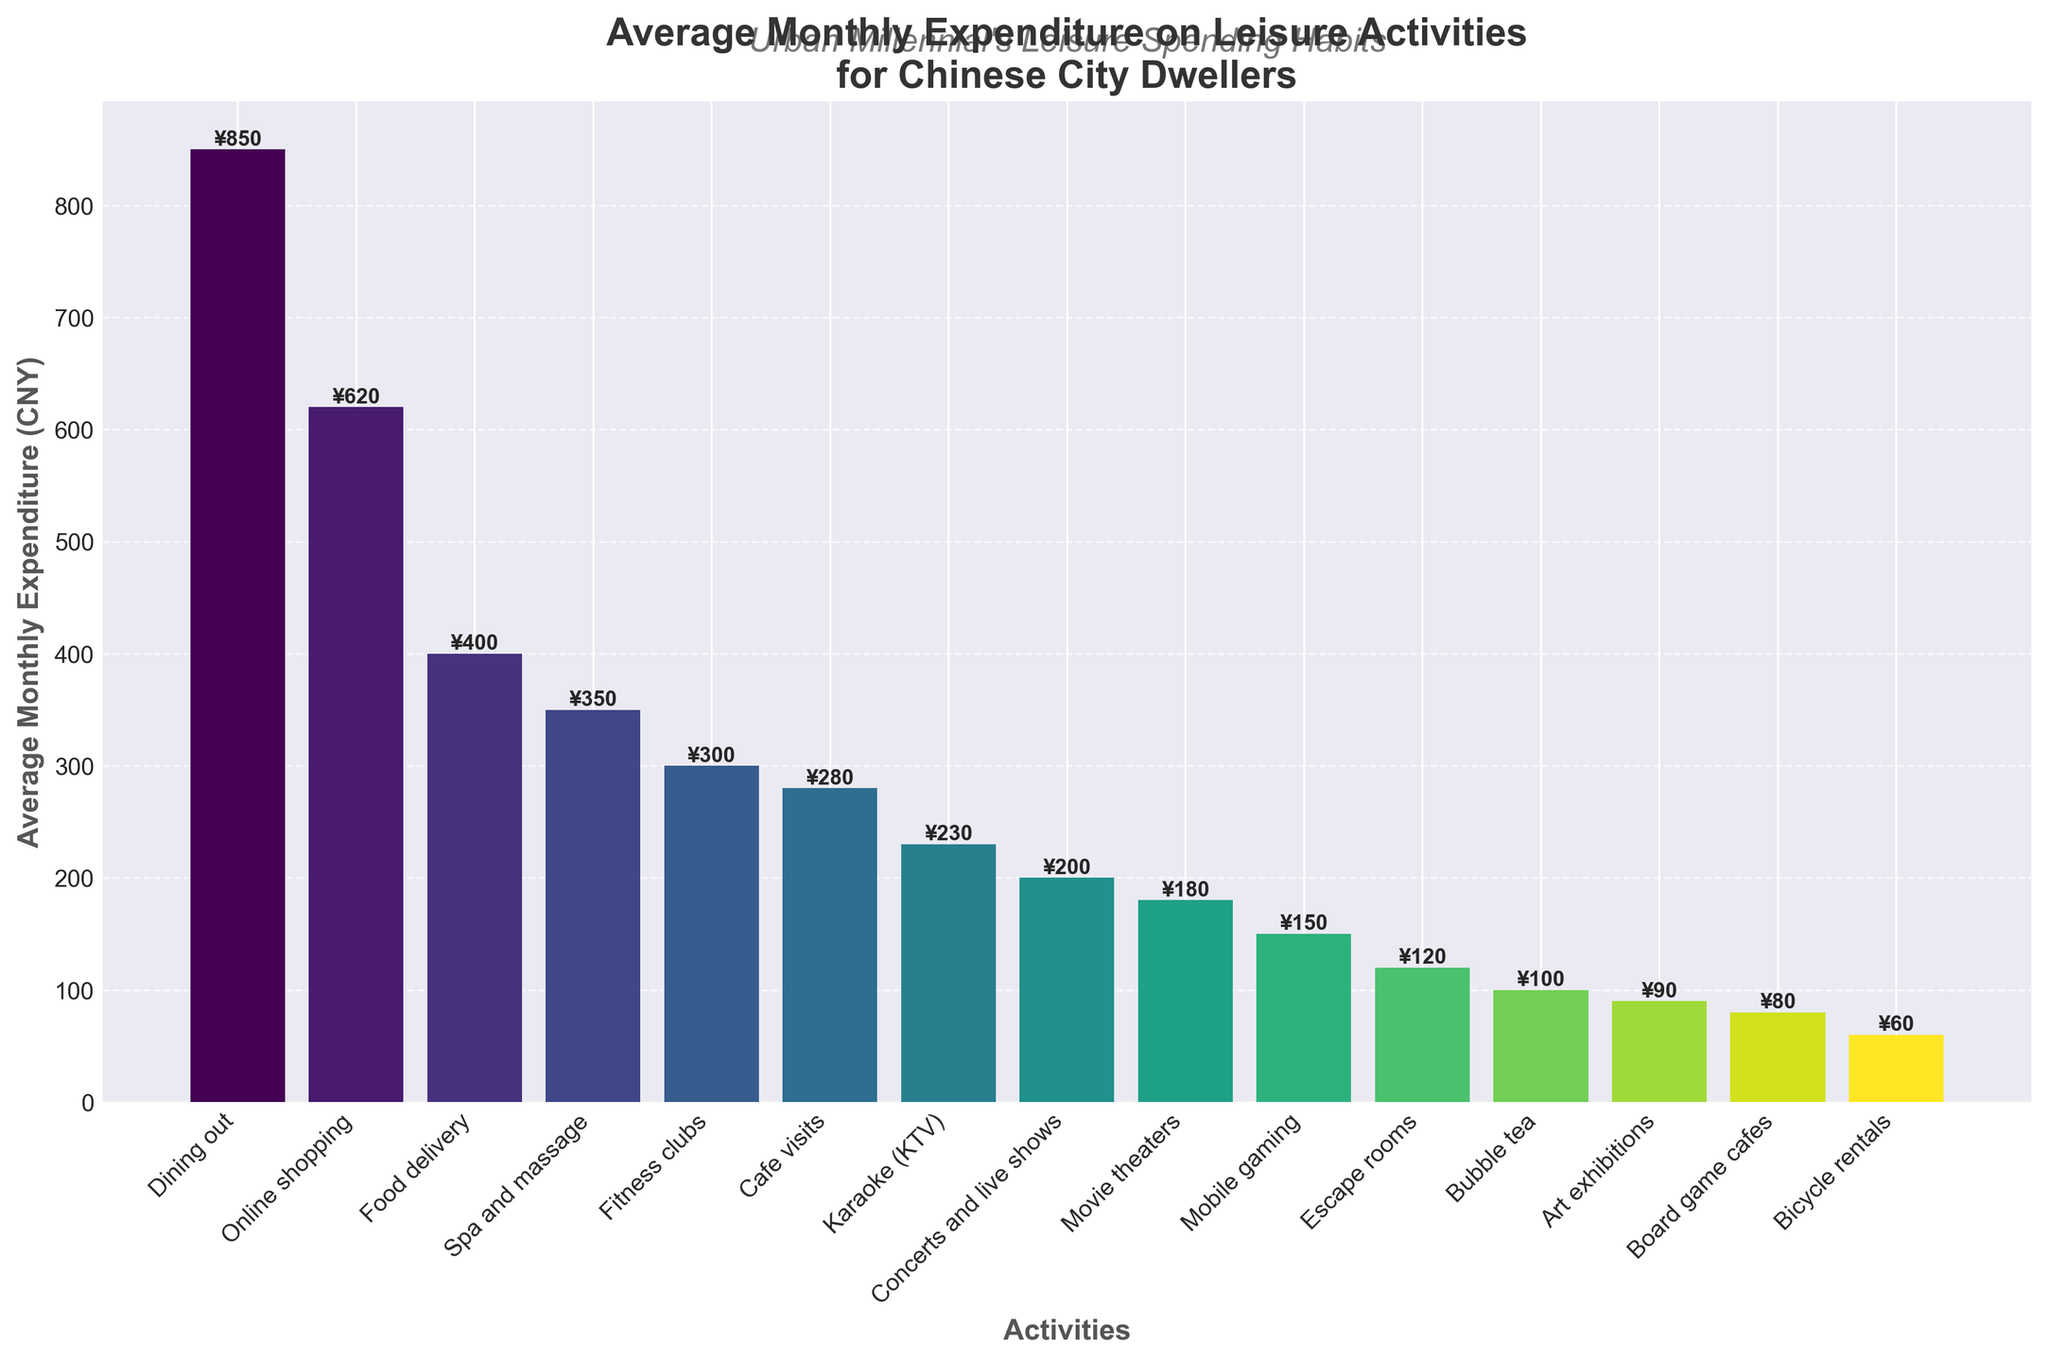What is the second most expensive leisure activity? From the figure, the most expensive activity is Dining out. The second bar after Dining out represents Food delivery, which has the second highest average monthly expenditure.
Answer: Food delivery What is the total monthly expenditure on both Cafe visits and Bike rentals? Cafe visits have a monthly expenditure of 280 CNY, and Bike rentals have a monthly expenditure of 60 CNY. Adding these together gives 280 + 60.
Answer: 340 CNY Which leisure activity has the least average monthly expenditure? The shortest bar represents the activity with the least expenditure, which is Bike rentals with an expenditure of 60 CNY.
Answer: Bike rentals How much more do city dwellers spend on Dining out compared to Art exhibitions? Dining out has an expenditure of 850 CNY, and Art exhibitions have an expenditure of 90 CNY. Subtracting 90 from 850 gives the difference.
Answer: 760 CNY Which activity's expenditure is exactly 350 CNY? The bar labeled with 350 CNY represents Spa and massage.
Answer: Spa and massage What is the combined expenditure on Mobile gaming, Bubble tea, and Escape rooms? Mobile gaming has an expenditure of 150 CNY, Bubble tea has 100 CNY, and Escape rooms have 120 CNY. Summing these gives 150 + 100 + 120.
Answer: 370 CNY Are there more activities with an expenditure above 300 CNY or below 300 CNY? Count the number of activities above and below 300 CNY. Activities above 300 CNY are Dining out, Food delivery, Spa and massage, and Fitness clubs (total 4). Activities below are the rest. Compare the two counts.
Answer: More below 300 CNY Which expenditure is higher: Fitness clubs or Karaoke (KTV)? From the figure, Fitness clubs have an expenditure of 300 CNY, whereas Karaoke (KTV) has 230 CNY.
Answer: Fitness clubs If you combine the expenditures on Dining out and Online shopping, what fraction of the total expenditure do they represent? Sum the expenditures for all activities to get the total. Then, sum Dining out (850) and Online shopping (620) and divide by the total expenditure. Calculate the fraction.
Answer: 0.306 How much more do city dwellers spend on Food delivery compared to Concerts and live shows? The average monthly expenditure on Food delivery is 400 CNY, and for Concerts and live shows, it is 200 CNY. Subtracting the latter from the former gives the difference.
Answer: 200 CNY 